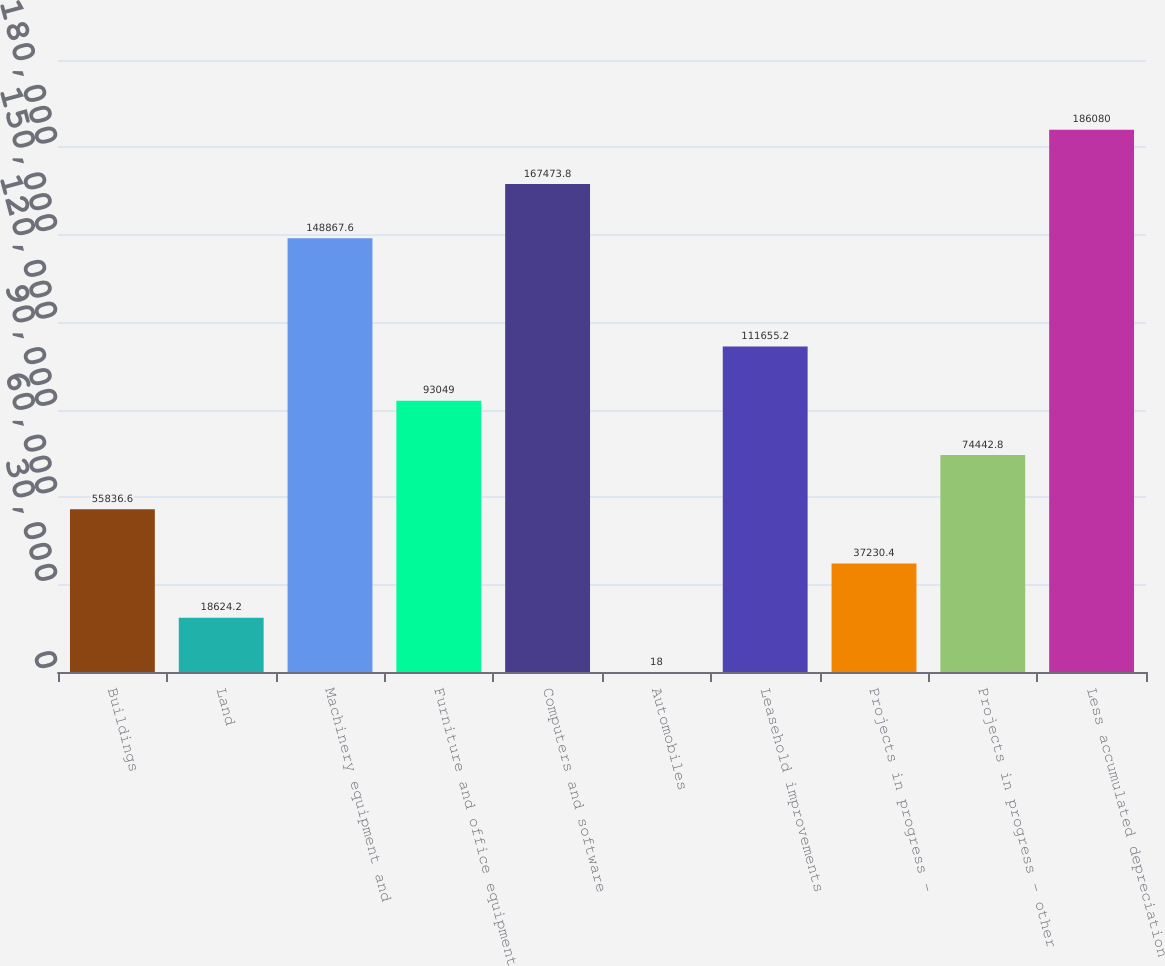<chart> <loc_0><loc_0><loc_500><loc_500><bar_chart><fcel>Buildings<fcel>Land<fcel>Machinery equipment and<fcel>Furniture and office equipment<fcel>Computers and software<fcel>Automobiles<fcel>Leasehold improvements<fcel>Projects in progress -<fcel>Projects in progress - other<fcel>Less accumulated depreciation<nl><fcel>55836.6<fcel>18624.2<fcel>148868<fcel>93049<fcel>167474<fcel>18<fcel>111655<fcel>37230.4<fcel>74442.8<fcel>186080<nl></chart> 